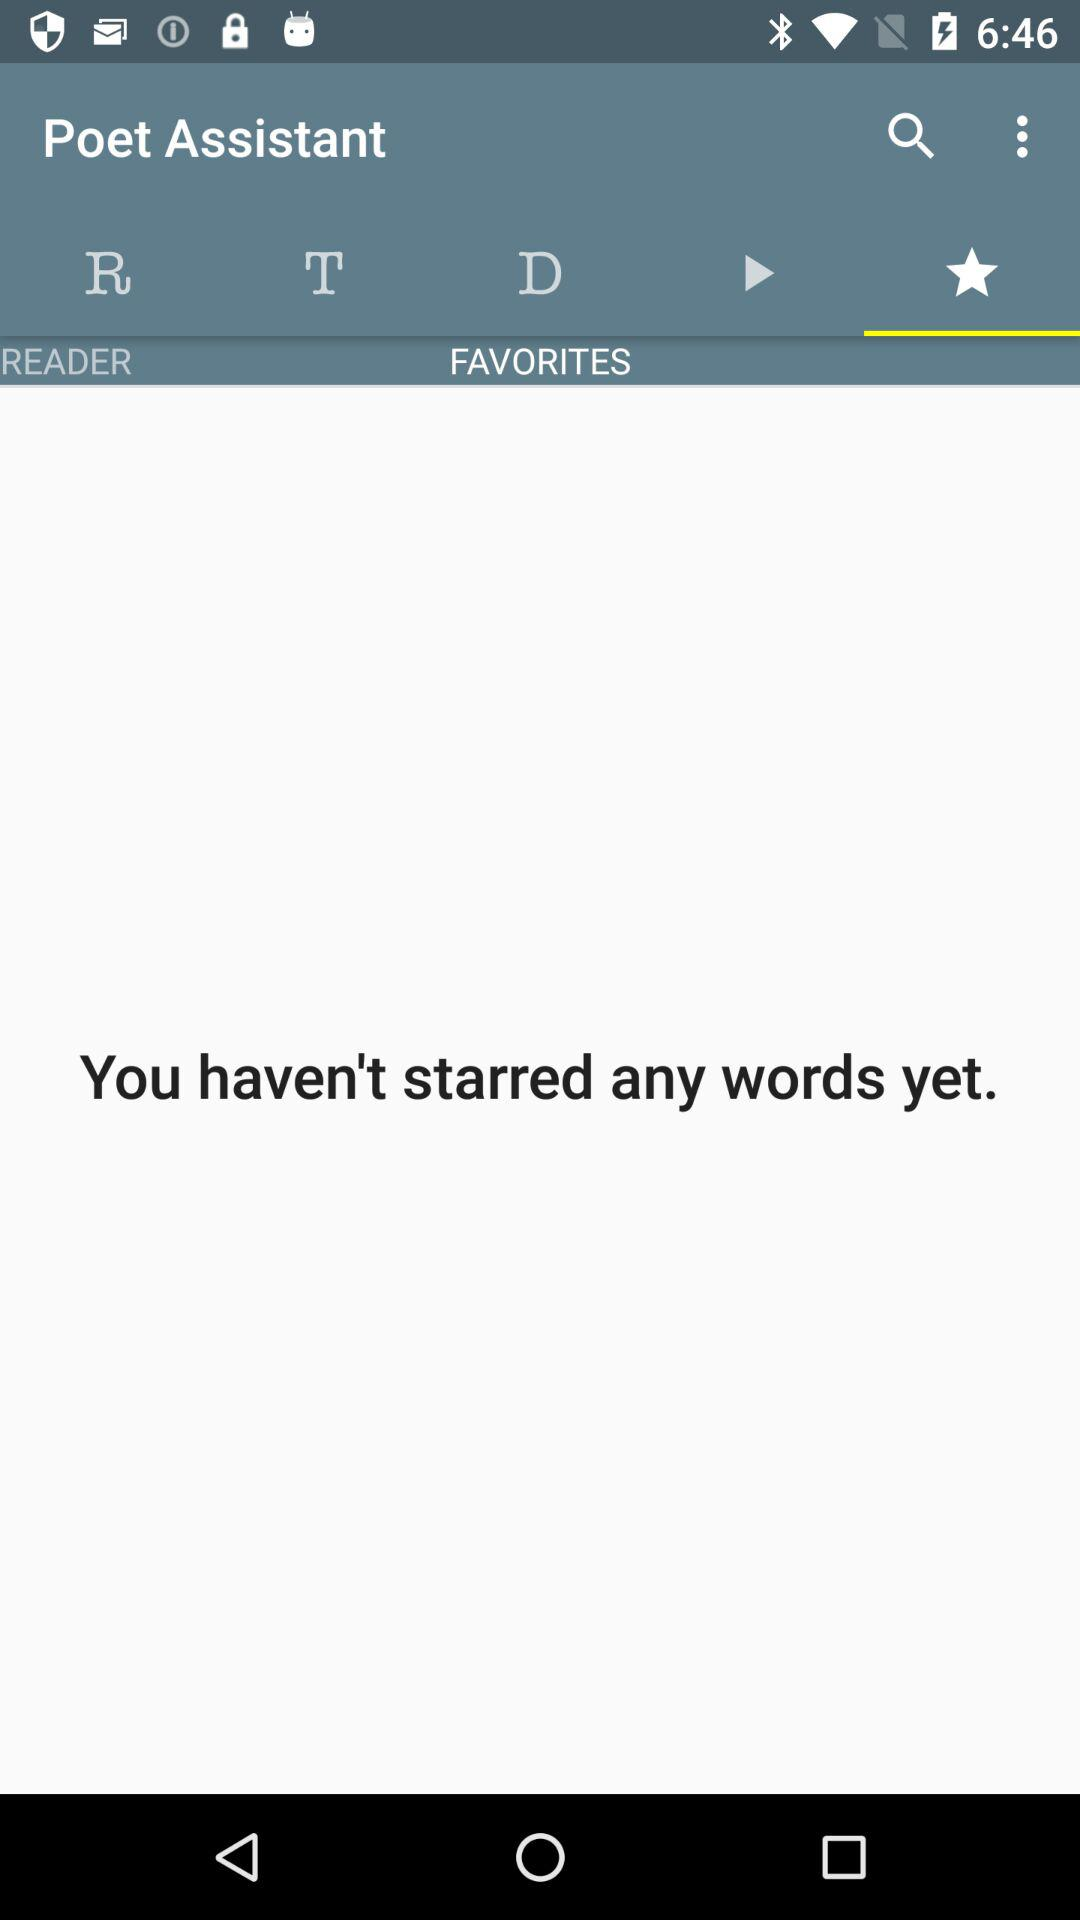How many readers are there?
When the provided information is insufficient, respond with <no answer>. <no answer> 